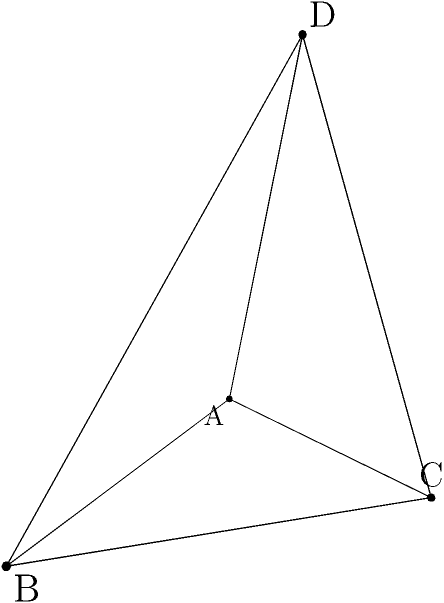Given a tetrahedron ABCD with vertices A(0,0,0), B(3,0,0), C(1,2,0), and D(1,1,3), calculate its volume. How does this seemingly abstract calculation relate to real-world applications in engineering or architecture? Let's approach this step-by-step:

1) The volume of a tetrahedron can be calculated using the formula:

   $$V = \frac{1}{6}|det(\vec{AB}, \vec{AC}, \vec{AD})|$$

   where $\vec{AB}$, $\vec{AC}$, and $\vec{AD}$ are vectors.

2) First, let's calculate these vectors:
   
   $\vec{AB} = B - A = (3,0,0) - (0,0,0) = (3,0,0)$
   $\vec{AC} = C - A = (1,2,0) - (0,0,0) = (1,2,0)$
   $\vec{AD} = D - A = (1,1,3) - (0,0,0) = (1,1,3)$

3) Now, we can set up our determinant:

   $$det = \begin{vmatrix} 
   3 & 1 & 1 \\
   0 & 2 & 1 \\
   0 & 0 & 3
   \end{vmatrix}$$

4) Calculating the determinant:

   $det = 3 * (2*3 - 0*1) - 1 * (0*3 - 0*1) + 1 * (0*1 - 2*0) = 18$

5) Finally, we can calculate the volume:

   $$V = \frac{1}{6}|18| = 3$$

This calculation, while seemingly abstract, has significant real-world applications. In engineering and architecture, accurate volume calculations are crucial for designing structures, estimating material costs, and ensuring structural integrity. For instance, in building design, knowing the exact volume of spaces helps in planning heating, ventilation, and air conditioning systems. In civil engineering, volume calculations are essential for earthwork operations, such as excavation and filling. The ability to precisely calculate volumes from coordinate points is particularly valuable in computer-aided design (CAD) and Building Information Modeling (BIM) systems, which are widely used in modern construction and manufacturing processes.
Answer: 3 cubic units 